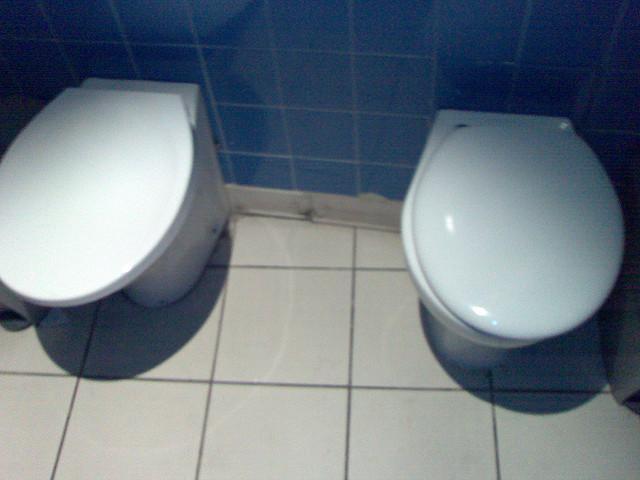How many toilets are there?
Give a very brief answer. 2. How many toilets are in the photo?
Give a very brief answer. 2. 